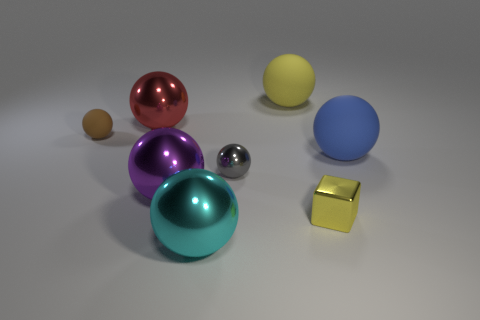Are there any balls that are on the right side of the large metallic object behind the big blue sphere?
Offer a terse response. Yes. What color is the other small thing that is the same shape as the brown matte object?
Offer a terse response. Gray. Is there any other thing that is the same shape as the small yellow thing?
Keep it short and to the point. No. What color is the other small thing that is made of the same material as the blue object?
Provide a succinct answer. Brown. Is there a object left of the purple object in front of the matte object that is on the left side of the cyan sphere?
Ensure brevity in your answer.  Yes. Are there fewer large yellow matte objects to the right of the big blue matte thing than metal objects in front of the small gray ball?
Give a very brief answer. Yes. What number of big balls have the same material as the tiny brown ball?
Ensure brevity in your answer.  2. Do the gray object and the yellow object that is in front of the purple metal ball have the same size?
Give a very brief answer. Yes. There is a large object that is the same color as the cube; what material is it?
Offer a terse response. Rubber. There is a yellow object that is in front of the yellow thing on the left side of the tiny metallic object in front of the large purple shiny thing; what is its size?
Keep it short and to the point. Small. 